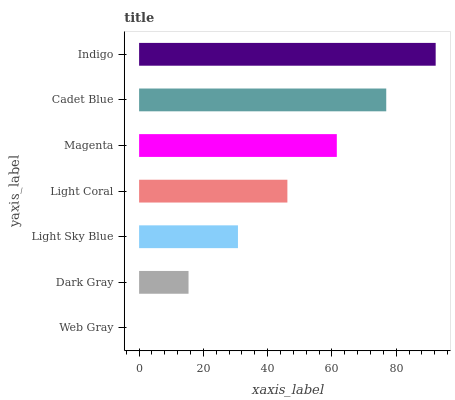Is Web Gray the minimum?
Answer yes or no. Yes. Is Indigo the maximum?
Answer yes or no. Yes. Is Dark Gray the minimum?
Answer yes or no. No. Is Dark Gray the maximum?
Answer yes or no. No. Is Dark Gray greater than Web Gray?
Answer yes or no. Yes. Is Web Gray less than Dark Gray?
Answer yes or no. Yes. Is Web Gray greater than Dark Gray?
Answer yes or no. No. Is Dark Gray less than Web Gray?
Answer yes or no. No. Is Light Coral the high median?
Answer yes or no. Yes. Is Light Coral the low median?
Answer yes or no. Yes. Is Magenta the high median?
Answer yes or no. No. Is Magenta the low median?
Answer yes or no. No. 